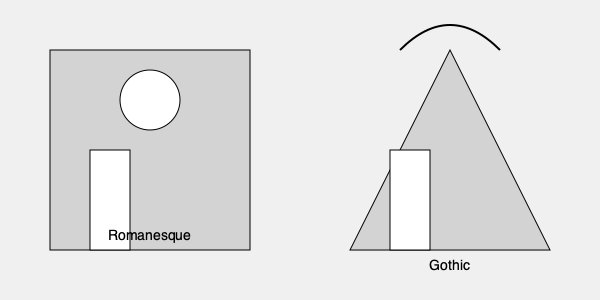Compare the architectural styles of Romanesque and Gothic cathedrals as depicted in the image. How do these styles reflect the historical and cultural shifts occurring during the medieval period, and what narrative elements might a writer incorporate to bring these architectural differences to life? 1. Romanesque style (left):
   - Characterized by thick, sturdy walls
   - Round arches and small windows
   - Horizontal emphasis, giving a sense of stability and earthiness
   - Reflects earlier medieval period (11th-12th centuries)
   - Narrative potential: Stories of fortress-like churches, protection from invaders

2. Gothic style (right):
   - Characterized by pointed arches and large windows
   - Vertical emphasis, creating a sense of height and reaching towards heaven
   - Flying buttresses (implied by the curved line) allowed for taller, thinner walls
   - Reflects later medieval period (12th-16th centuries)
   - Narrative potential: Tales of spiritual ascension, light symbolism, architectural innovation

3. Historical and cultural shifts:
   - Transition from defensive, insular societies to more interconnected, prosperous ones
   - Advancements in engineering and construction techniques
   - Changing religious philosophies and expressions of faith
   - Growing wealth and competition among cities to build grander cathedrals

4. Narrative elements for a writer:
   - Contrast the experience of worshippers in each style of cathedral
   - Explore the lives of the craftsmen and architects behind these structures
   - Describe the symbolic meanings behind architectural elements
   - Create characters whose personal journeys mirror the transition from Romanesque to Gothic periods
   - Use the cathedrals as backdrops for historical events or personal dramas

5. Significance for an aspiring writer:
   - These architectural styles provide rich settings for medieval narratives
   - Understanding the symbolism and cultural context adds depth to storytelling
   - The evolution of styles parallels character development and societal changes
Answer: Romanesque: thick walls, round arches, small windows, horizontal emphasis. Gothic: pointed arches, large windows, vertical emphasis, flying buttresses. Reflect transition from defensive to prosperous societies, engineering advancements, and evolving religious expression. Writers can use these as symbolic backdrops for character and societal development in medieval narratives. 